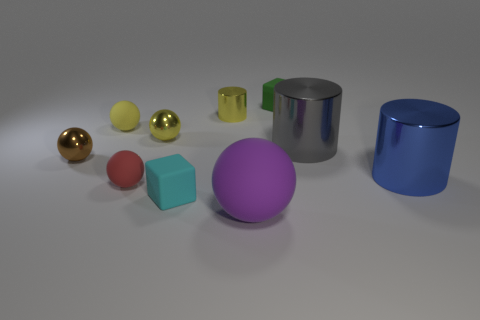Subtract all tiny metal cylinders. How many cylinders are left? 2 Subtract all red spheres. How many spheres are left? 4 Subtract all cylinders. How many objects are left? 7 Subtract 2 balls. How many balls are left? 3 Subtract all blue cylinders. Subtract all blue balls. How many cylinders are left? 2 Subtract all red balls. How many yellow cylinders are left? 1 Subtract all red balls. Subtract all brown shiny objects. How many objects are left? 8 Add 7 large cylinders. How many large cylinders are left? 9 Add 3 large purple objects. How many large purple objects exist? 4 Subtract 1 blue cylinders. How many objects are left? 9 